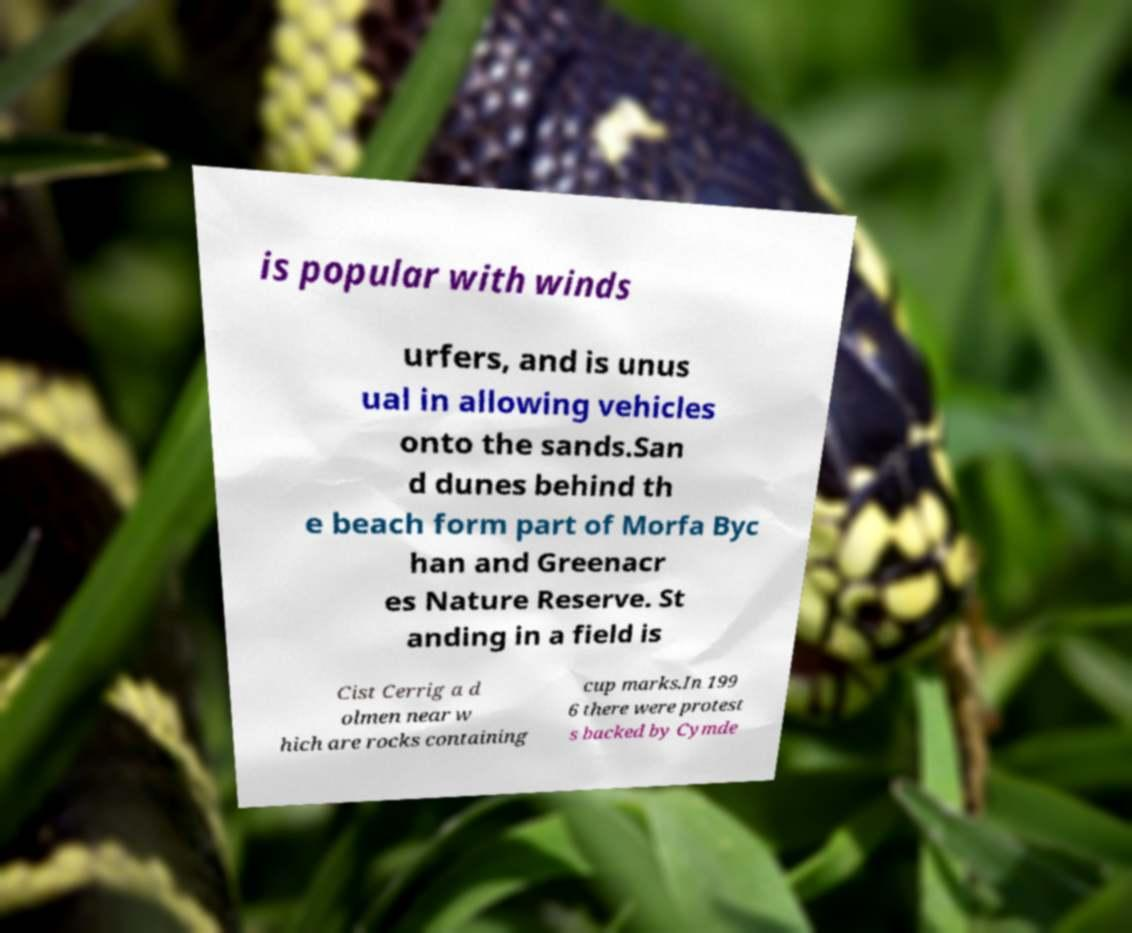Please read and relay the text visible in this image. What does it say? is popular with winds urfers, and is unus ual in allowing vehicles onto the sands.San d dunes behind th e beach form part of Morfa Byc han and Greenacr es Nature Reserve. St anding in a field is Cist Cerrig a d olmen near w hich are rocks containing cup marks.In 199 6 there were protest s backed by Cymde 